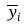Convert formula to latex. <formula><loc_0><loc_0><loc_500><loc_500>\overline { y } _ { i }</formula> 